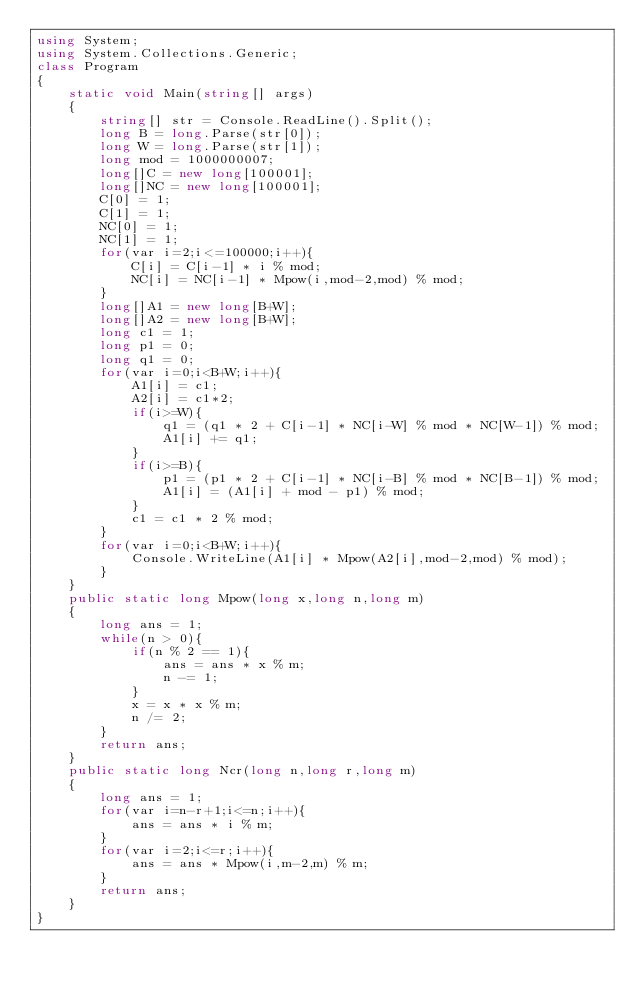<code> <loc_0><loc_0><loc_500><loc_500><_C#_>using System;
using System.Collections.Generic;
class Program
{
	static void Main(string[] args)
	{
		string[] str = Console.ReadLine().Split();
		long B = long.Parse(str[0]);
		long W = long.Parse(str[1]);
		long mod = 1000000007;
		long[]C = new long[100001];
		long[]NC = new long[100001];
        C[0] = 1;
		C[1] = 1;
		NC[0] = 1;
		NC[1] = 1;
		for(var i=2;i<=100000;i++){
			C[i] = C[i-1] * i % mod;
			NC[i] = NC[i-1] * Mpow(i,mod-2,mod) % mod;
		}
		long[]A1 = new long[B+W];
		long[]A2 = new long[B+W];
		long c1 = 1;
		long p1 = 0;
		long q1 = 0;
		for(var i=0;i<B+W;i++){
			A1[i] = c1;
			A2[i] = c1*2;
			if(i>=W){
				q1 = (q1 * 2 + C[i-1] * NC[i-W] % mod * NC[W-1]) % mod;
				A1[i] += q1;
			}
			if(i>=B){
				p1 = (p1 * 2 + C[i-1] * NC[i-B] % mod * NC[B-1]) % mod;
				A1[i] = (A1[i] + mod - p1) % mod;
			}
			c1 = c1 * 2 % mod;
		}
		for(var i=0;i<B+W;i++){
			Console.WriteLine(A1[i] * Mpow(A2[i],mod-2,mod) % mod);
		}
	}
	public static long Mpow(long x,long n,long m)
	{
		long ans = 1;
		while(n > 0){
			if(n % 2 == 1){
				ans = ans * x % m;
				n -= 1;
			}
			x = x * x % m;
			n /= 2;
		}
		return ans;
	}
	public static long Ncr(long n,long r,long m)
	{
		long ans = 1;
		for(var i=n-r+1;i<=n;i++){
			ans = ans * i % m;
		}
		for(var i=2;i<=r;i++){
			ans = ans * Mpow(i,m-2,m) % m;
		}
		return ans;
	}
}</code> 